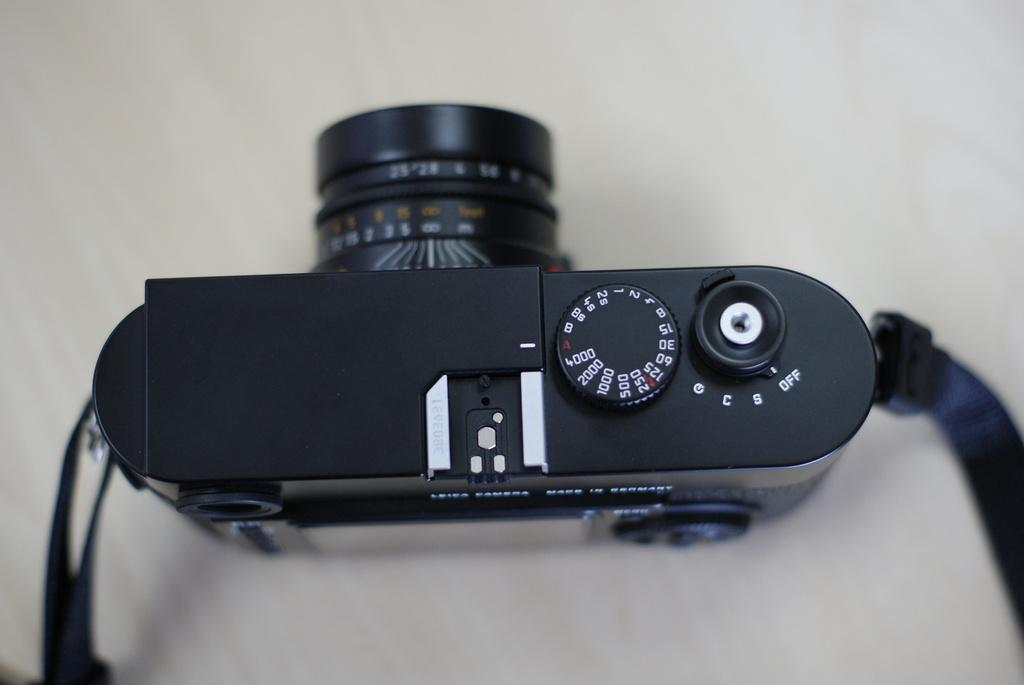What is the main object in the image? There is a camera in the image. What color is the background of the image? The background of the image is white. What type of voyage is the camera embarking on in the image? There is no indication of a voyage in the image; it simply shows a camera with a white background. 